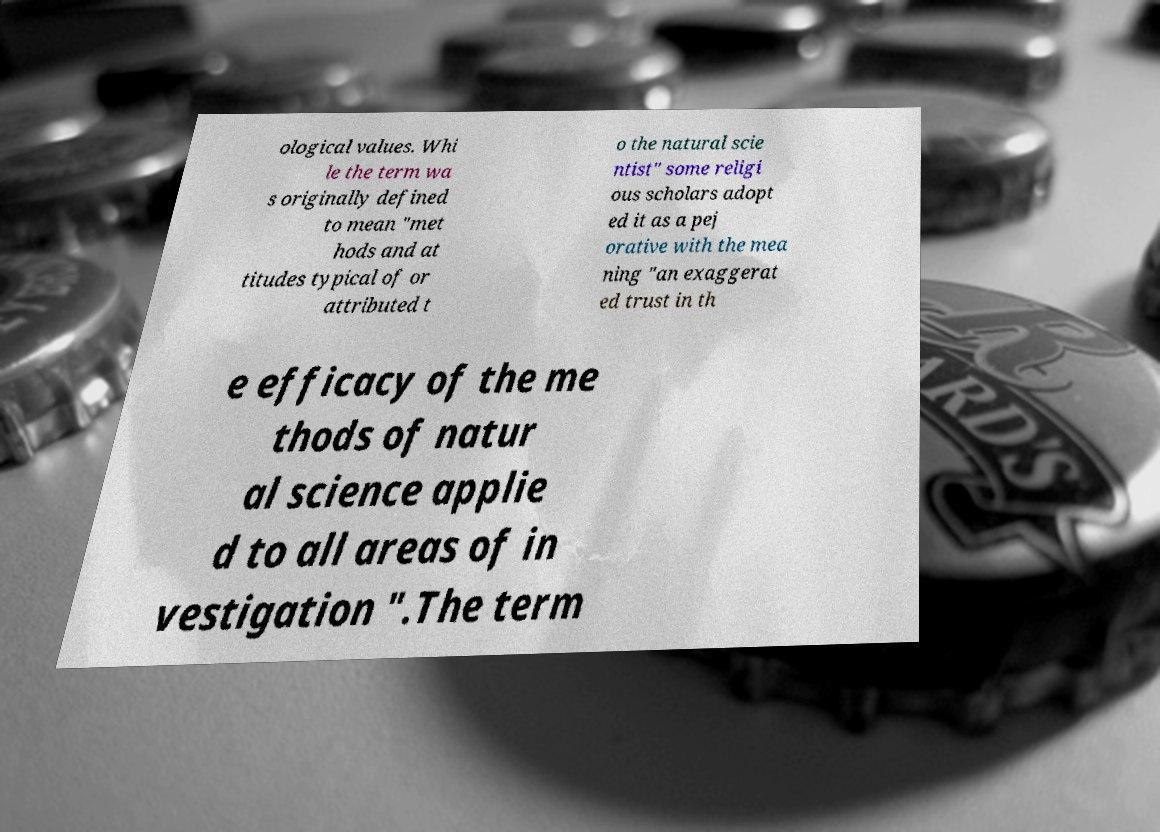What messages or text are displayed in this image? I need them in a readable, typed format. ological values. Whi le the term wa s originally defined to mean "met hods and at titudes typical of or attributed t o the natural scie ntist" some religi ous scholars adopt ed it as a pej orative with the mea ning "an exaggerat ed trust in th e efficacy of the me thods of natur al science applie d to all areas of in vestigation ".The term 